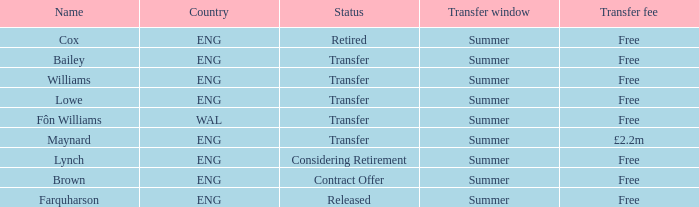What is the title of the complimentary transfer charge with a transfer condition and an eng nation? Bailey, Williams, Lowe. 